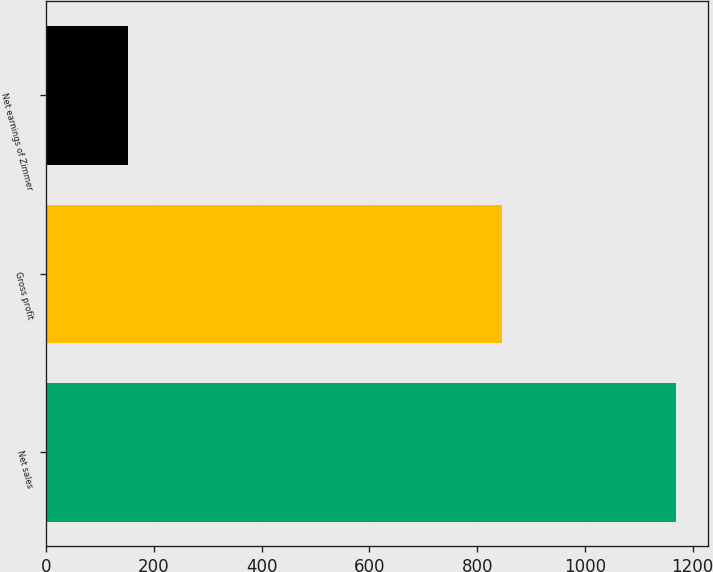Convert chart. <chart><loc_0><loc_0><loc_500><loc_500><bar_chart><fcel>Net sales<fcel>Gross profit<fcel>Net earnings of Zimmer<nl><fcel>1169.5<fcel>845.9<fcel>152.1<nl></chart> 